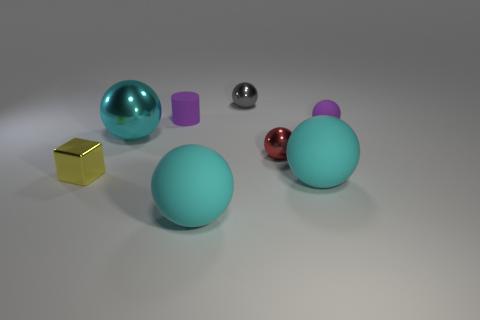Subtract 4 balls. How many balls are left? 2 Subtract all blue cubes. How many cyan balls are left? 3 Subtract all red balls. How many balls are left? 5 Subtract all cyan rubber spheres. How many spheres are left? 4 Subtract all yellow balls. Subtract all yellow cylinders. How many balls are left? 6 Add 2 spheres. How many objects exist? 10 Subtract all blocks. How many objects are left? 7 Subtract all balls. Subtract all big cyan shiny objects. How many objects are left? 1 Add 5 purple rubber balls. How many purple rubber balls are left? 6 Add 8 cyan metallic balls. How many cyan metallic balls exist? 9 